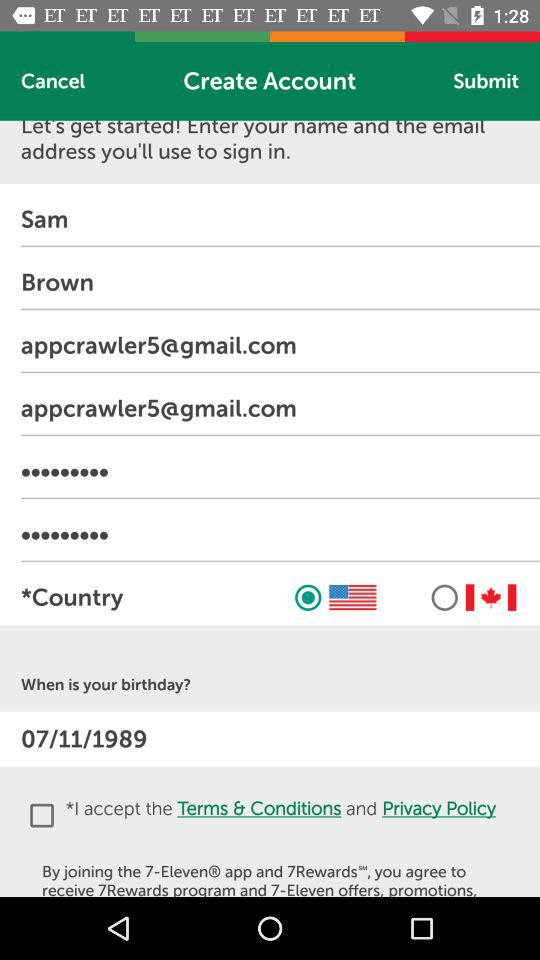What is the email address? The email address is appcrawler5@gmail.com. 